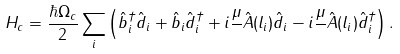<formula> <loc_0><loc_0><loc_500><loc_500>H _ { c } = \frac { \hbar { \Omega } _ { c } } { 2 } \sum _ { i } \left ( \hat { b } ^ { \dagger } _ { i } \hat { d } _ { i } + \hat { b } _ { i } \hat { d } ^ { \dagger } _ { i } + i \frac { \mu } { } \hat { A } ( l _ { i } ) \hat { d } _ { i } - i \frac { \mu } { } \hat { A } ( l _ { i } ) \hat { d } ^ { \dagger } _ { i } \right ) .</formula> 